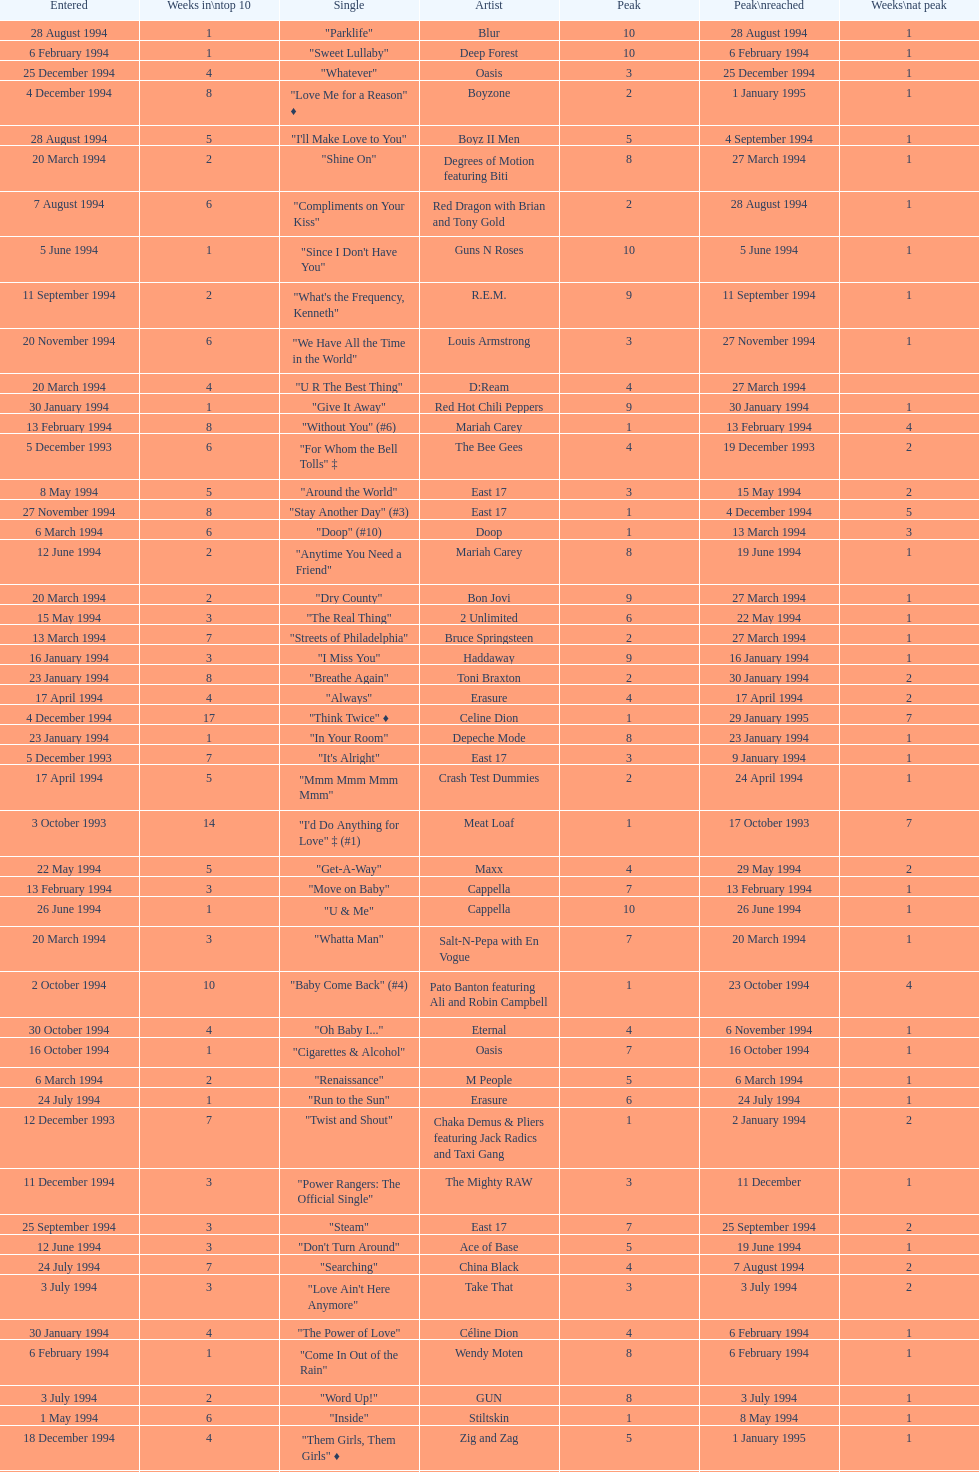Which single was the last one to be on the charts in 1993? "Come Baby Come". 